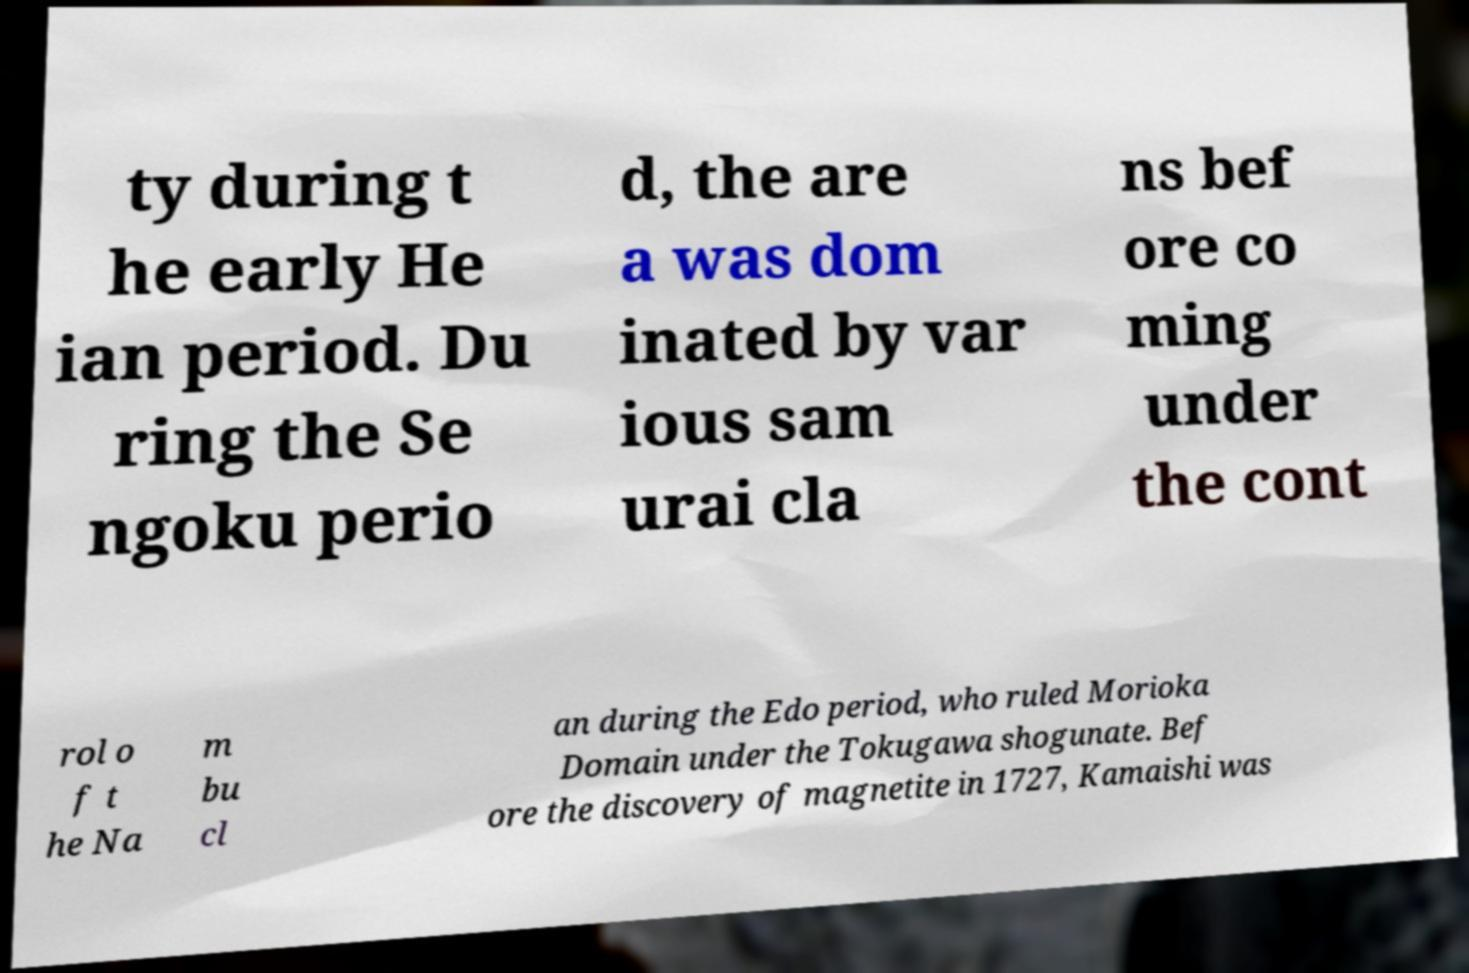Please identify and transcribe the text found in this image. ty during t he early He ian period. Du ring the Se ngoku perio d, the are a was dom inated by var ious sam urai cla ns bef ore co ming under the cont rol o f t he Na m bu cl an during the Edo period, who ruled Morioka Domain under the Tokugawa shogunate. Bef ore the discovery of magnetite in 1727, Kamaishi was 